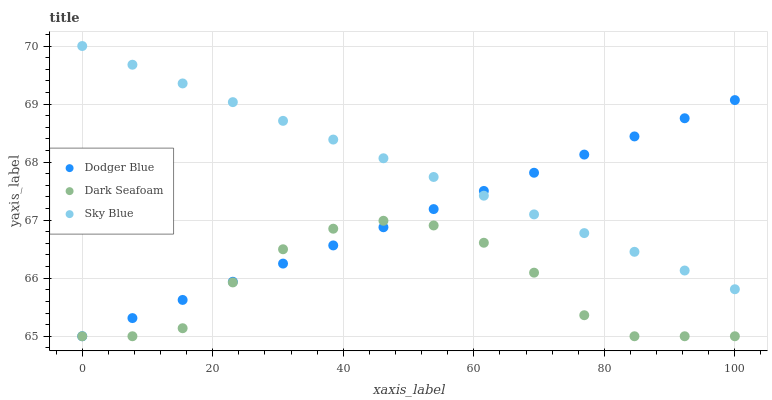Does Dark Seafoam have the minimum area under the curve?
Answer yes or no. Yes. Does Sky Blue have the maximum area under the curve?
Answer yes or no. Yes. Does Dodger Blue have the minimum area under the curve?
Answer yes or no. No. Does Dodger Blue have the maximum area under the curve?
Answer yes or no. No. Is Sky Blue the smoothest?
Answer yes or no. Yes. Is Dark Seafoam the roughest?
Answer yes or no. Yes. Is Dodger Blue the smoothest?
Answer yes or no. No. Is Dodger Blue the roughest?
Answer yes or no. No. Does Dark Seafoam have the lowest value?
Answer yes or no. Yes. Does Sky Blue have the highest value?
Answer yes or no. Yes. Does Dodger Blue have the highest value?
Answer yes or no. No. Is Dark Seafoam less than Sky Blue?
Answer yes or no. Yes. Is Sky Blue greater than Dark Seafoam?
Answer yes or no. Yes. Does Sky Blue intersect Dodger Blue?
Answer yes or no. Yes. Is Sky Blue less than Dodger Blue?
Answer yes or no. No. Is Sky Blue greater than Dodger Blue?
Answer yes or no. No. Does Dark Seafoam intersect Sky Blue?
Answer yes or no. No. 